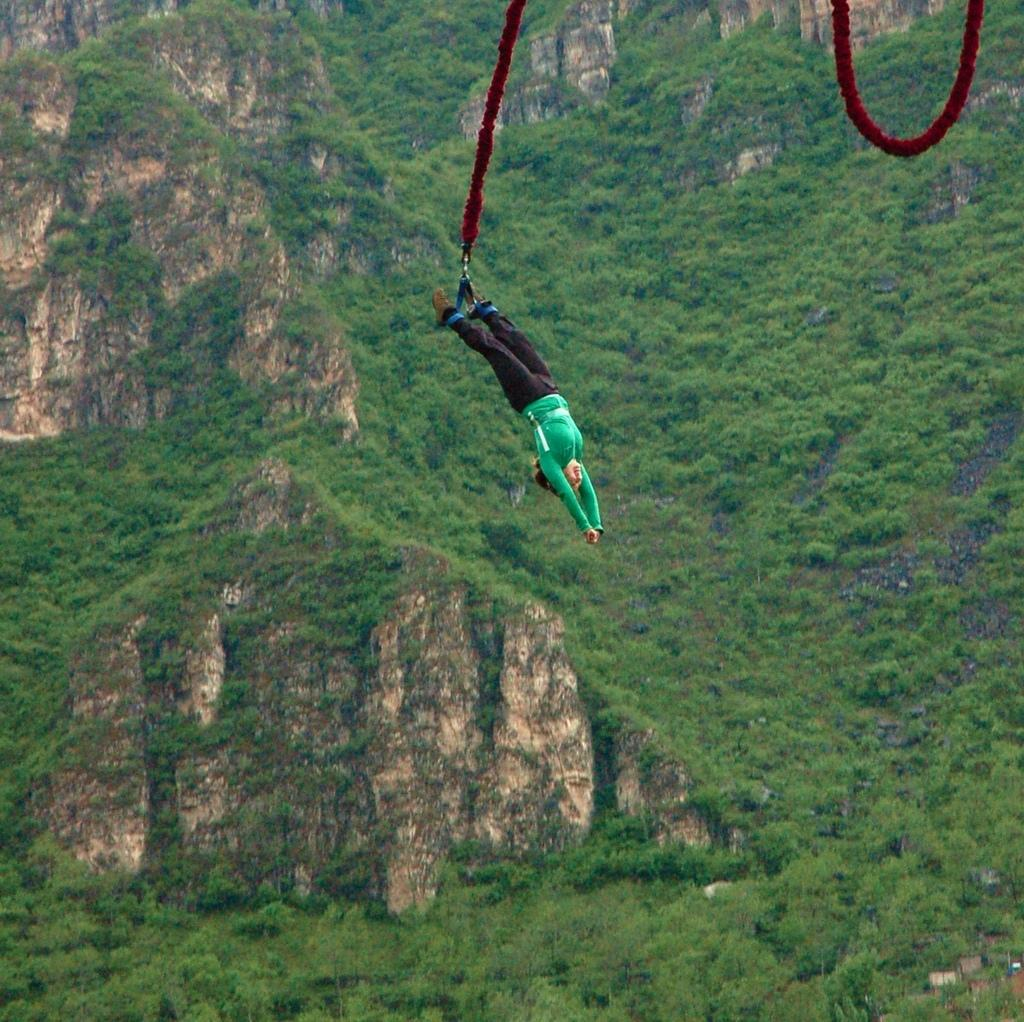What activity is the person in the image participating in? The person in the image is performing bungee jumping. What can be seen in the background of the image? There is a huge mountain in the background of the image. How many people are in the jail in the image? There is no jail present in the image; it features a person bungee jumping with a mountain in the background. What type of shoes is the team wearing in the image? There is no team present in the image, only a person performing bungee jumping. 